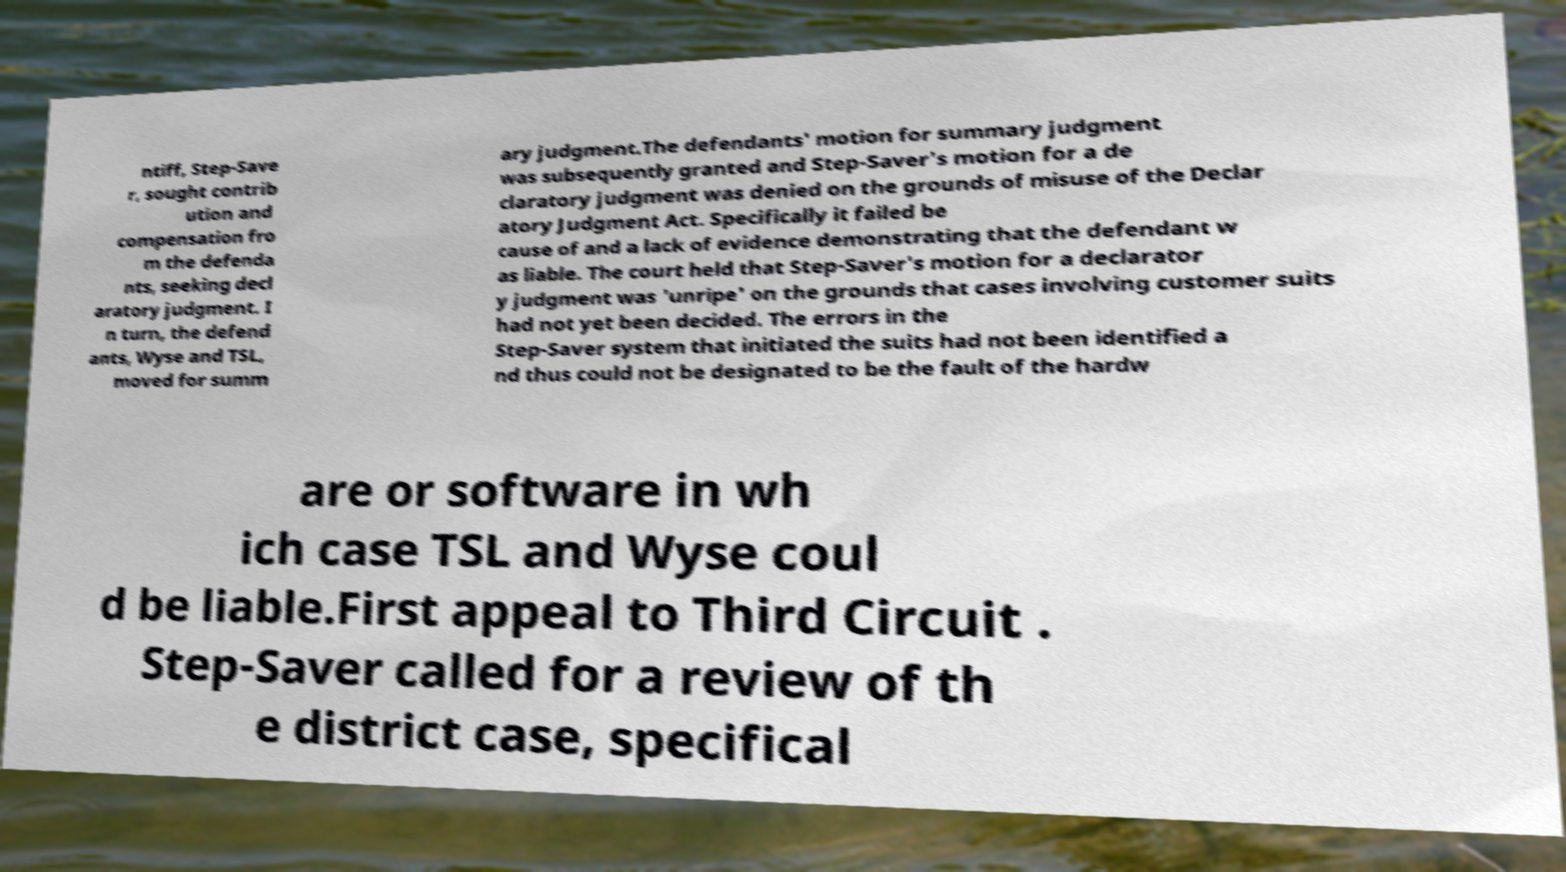Could you extract and type out the text from this image? ntiff, Step-Save r, sought contrib ution and compensation fro m the defenda nts, seeking decl aratory judgment. I n turn, the defend ants, Wyse and TSL, moved for summ ary judgment.The defendants' motion for summary judgment was subsequently granted and Step-Saver's motion for a de claratory judgment was denied on the grounds of misuse of the Declar atory Judgment Act. Specifically it failed be cause of and a lack of evidence demonstrating that the defendant w as liable. The court held that Step-Saver's motion for a declarator y judgment was 'unripe' on the grounds that cases involving customer suits had not yet been decided. The errors in the Step-Saver system that initiated the suits had not been identified a nd thus could not be designated to be the fault of the hardw are or software in wh ich case TSL and Wyse coul d be liable.First appeal to Third Circuit . Step-Saver called for a review of th e district case, specifical 